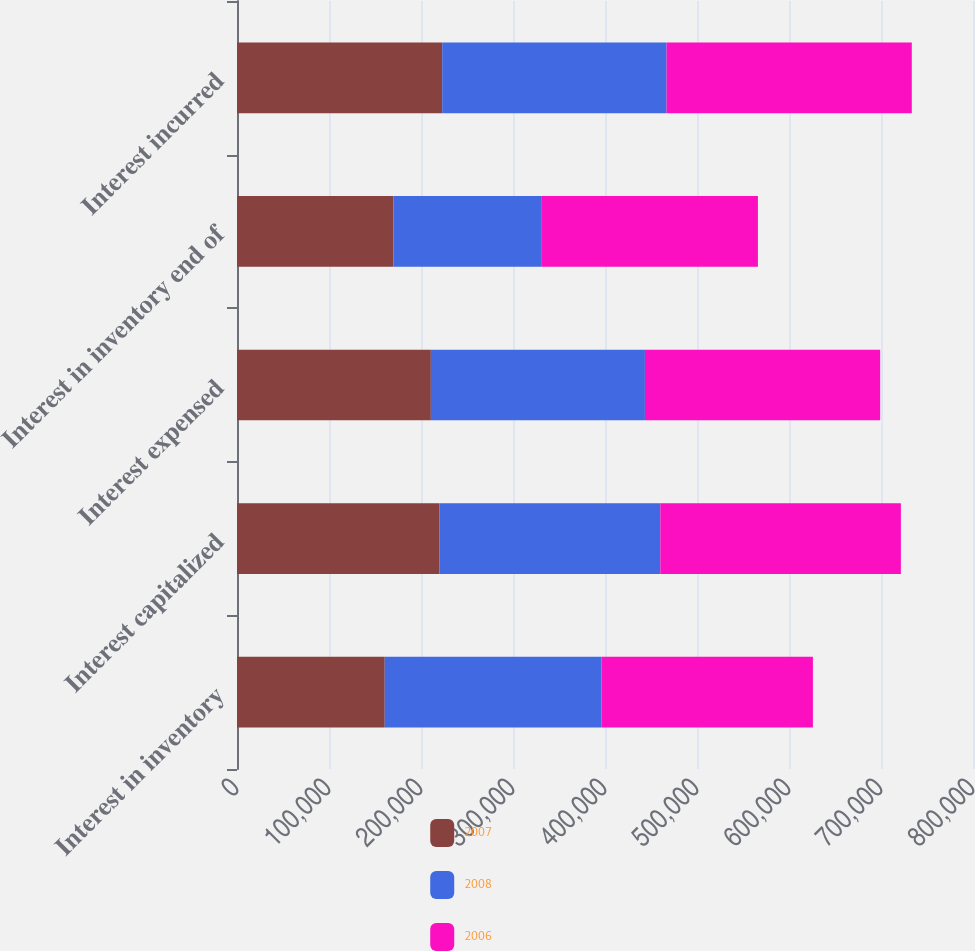Convert chart to OTSL. <chart><loc_0><loc_0><loc_500><loc_500><stacked_bar_chart><ecel><fcel>Interest in inventory<fcel>Interest capitalized<fcel>Interest expensed<fcel>Interest in inventory end of<fcel>Interest incurred<nl><fcel>2007<fcel>160598<fcel>220131<fcel>210709<fcel>170020<fcel>223039<nl><fcel>2008<fcel>235596<fcel>240000<fcel>232697<fcel>160598<fcel>243864<nl><fcel>2006<fcel>229798<fcel>261486<fcel>255688<fcel>235596<fcel>266561<nl></chart> 